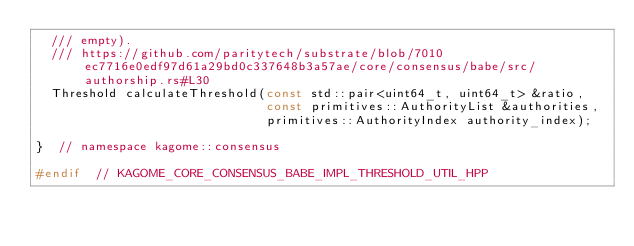<code> <loc_0><loc_0><loc_500><loc_500><_C++_>  /// empty).
  /// https://github.com/paritytech/substrate/blob/7010ec7716e0edf97d61a29bd0c337648b3a57ae/core/consensus/babe/src/authorship.rs#L30
  Threshold calculateThreshold(const std::pair<uint64_t, uint64_t> &ratio,
                               const primitives::AuthorityList &authorities,
                               primitives::AuthorityIndex authority_index);

}  // namespace kagome::consensus

#endif  // KAGOME_CORE_CONSENSUS_BABE_IMPL_THRESHOLD_UTIL_HPP
</code> 